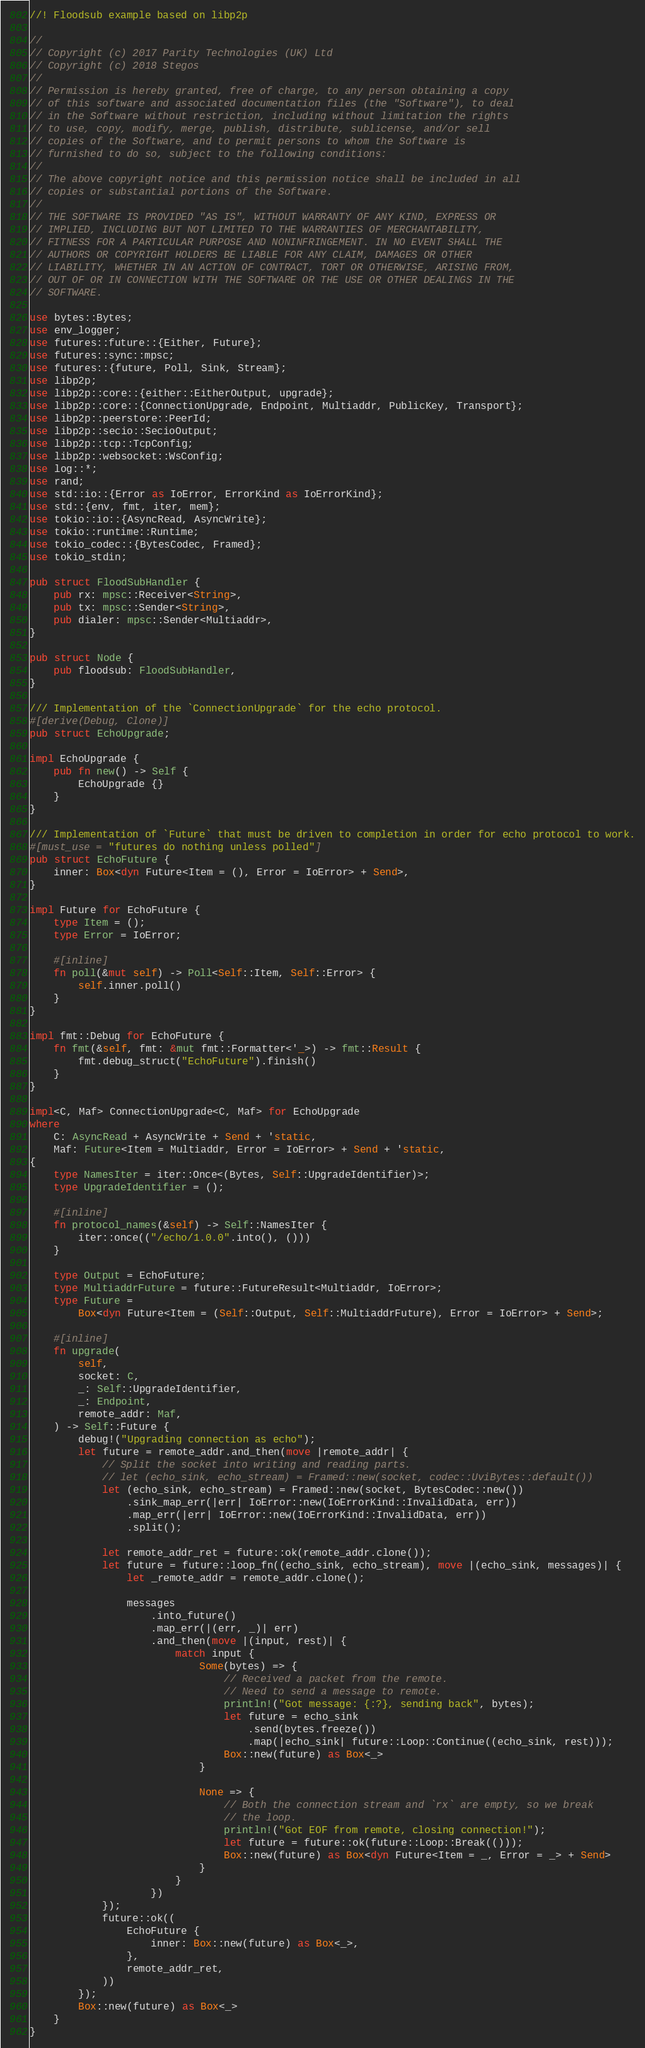Convert code to text. <code><loc_0><loc_0><loc_500><loc_500><_Rust_>//! Floodsub example based on libp2p

//
// Copyright (c) 2017 Parity Technologies (UK) Ltd
// Copyright (c) 2018 Stegos
//
// Permission is hereby granted, free of charge, to any person obtaining a copy
// of this software and associated documentation files (the "Software"), to deal
// in the Software without restriction, including without limitation the rights
// to use, copy, modify, merge, publish, distribute, sublicense, and/or sell
// copies of the Software, and to permit persons to whom the Software is
// furnished to do so, subject to the following conditions:
//
// The above copyright notice and this permission notice shall be included in all
// copies or substantial portions of the Software.
//
// THE SOFTWARE IS PROVIDED "AS IS", WITHOUT WARRANTY OF ANY KIND, EXPRESS OR
// IMPLIED, INCLUDING BUT NOT LIMITED TO THE WARRANTIES OF MERCHANTABILITY,
// FITNESS FOR A PARTICULAR PURPOSE AND NONINFRINGEMENT. IN NO EVENT SHALL THE
// AUTHORS OR COPYRIGHT HOLDERS BE LIABLE FOR ANY CLAIM, DAMAGES OR OTHER
// LIABILITY, WHETHER IN AN ACTION OF CONTRACT, TORT OR OTHERWISE, ARISING FROM,
// OUT OF OR IN CONNECTION WITH THE SOFTWARE OR THE USE OR OTHER DEALINGS IN THE
// SOFTWARE.

use bytes::Bytes;
use env_logger;
use futures::future::{Either, Future};
use futures::sync::mpsc;
use futures::{future, Poll, Sink, Stream};
use libp2p;
use libp2p::core::{either::EitherOutput, upgrade};
use libp2p::core::{ConnectionUpgrade, Endpoint, Multiaddr, PublicKey, Transport};
use libp2p::peerstore::PeerId;
use libp2p::secio::SecioOutput;
use libp2p::tcp::TcpConfig;
use libp2p::websocket::WsConfig;
use log::*;
use rand;
use std::io::{Error as IoError, ErrorKind as IoErrorKind};
use std::{env, fmt, iter, mem};
use tokio::io::{AsyncRead, AsyncWrite};
use tokio::runtime::Runtime;
use tokio_codec::{BytesCodec, Framed};
use tokio_stdin;

pub struct FloodSubHandler {
    pub rx: mpsc::Receiver<String>,
    pub tx: mpsc::Sender<String>,
    pub dialer: mpsc::Sender<Multiaddr>,
}

pub struct Node {
    pub floodsub: FloodSubHandler,
}

/// Implementation of the `ConnectionUpgrade` for the echo protocol.
#[derive(Debug, Clone)]
pub struct EchoUpgrade;

impl EchoUpgrade {
    pub fn new() -> Self {
        EchoUpgrade {}
    }
}

/// Implementation of `Future` that must be driven to completion in order for echo protocol to work.
#[must_use = "futures do nothing unless polled"]
pub struct EchoFuture {
    inner: Box<dyn Future<Item = (), Error = IoError> + Send>,
}

impl Future for EchoFuture {
    type Item = ();
    type Error = IoError;

    #[inline]
    fn poll(&mut self) -> Poll<Self::Item, Self::Error> {
        self.inner.poll()
    }
}

impl fmt::Debug for EchoFuture {
    fn fmt(&self, fmt: &mut fmt::Formatter<'_>) -> fmt::Result {
        fmt.debug_struct("EchoFuture").finish()
    }
}

impl<C, Maf> ConnectionUpgrade<C, Maf> for EchoUpgrade
where
    C: AsyncRead + AsyncWrite + Send + 'static,
    Maf: Future<Item = Multiaddr, Error = IoError> + Send + 'static,
{
    type NamesIter = iter::Once<(Bytes, Self::UpgradeIdentifier)>;
    type UpgradeIdentifier = ();

    #[inline]
    fn protocol_names(&self) -> Self::NamesIter {
        iter::once(("/echo/1.0.0".into(), ()))
    }

    type Output = EchoFuture;
    type MultiaddrFuture = future::FutureResult<Multiaddr, IoError>;
    type Future =
        Box<dyn Future<Item = (Self::Output, Self::MultiaddrFuture), Error = IoError> + Send>;

    #[inline]
    fn upgrade(
        self,
        socket: C,
        _: Self::UpgradeIdentifier,
        _: Endpoint,
        remote_addr: Maf,
    ) -> Self::Future {
        debug!("Upgrading connection as echo");
        let future = remote_addr.and_then(move |remote_addr| {
            // Split the socket into writing and reading parts.
            // let (echo_sink, echo_stream) = Framed::new(socket, codec::UviBytes::default())
            let (echo_sink, echo_stream) = Framed::new(socket, BytesCodec::new())
                .sink_map_err(|err| IoError::new(IoErrorKind::InvalidData, err))
                .map_err(|err| IoError::new(IoErrorKind::InvalidData, err))
                .split();

            let remote_addr_ret = future::ok(remote_addr.clone());
            let future = future::loop_fn((echo_sink, echo_stream), move |(echo_sink, messages)| {
                let _remote_addr = remote_addr.clone();

                messages
                    .into_future()
                    .map_err(|(err, _)| err)
                    .and_then(move |(input, rest)| {
                        match input {
                            Some(bytes) => {
                                // Received a packet from the remote.
                                // Need to send a message to remote.
                                println!("Got message: {:?}, sending back", bytes);
                                let future = echo_sink
                                    .send(bytes.freeze())
                                    .map(|echo_sink| future::Loop::Continue((echo_sink, rest)));
                                Box::new(future) as Box<_>
                            }

                            None => {
                                // Both the connection stream and `rx` are empty, so we break
                                // the loop.
                                println!("Got EOF from remote, closing connection!");
                                let future = future::ok(future::Loop::Break(()));
                                Box::new(future) as Box<dyn Future<Item = _, Error = _> + Send>
                            }
                        }
                    })
            });
            future::ok((
                EchoFuture {
                    inner: Box::new(future) as Box<_>,
                },
                remote_addr_ret,
            ))
        });
        Box::new(future) as Box<_>
    }
}
</code> 